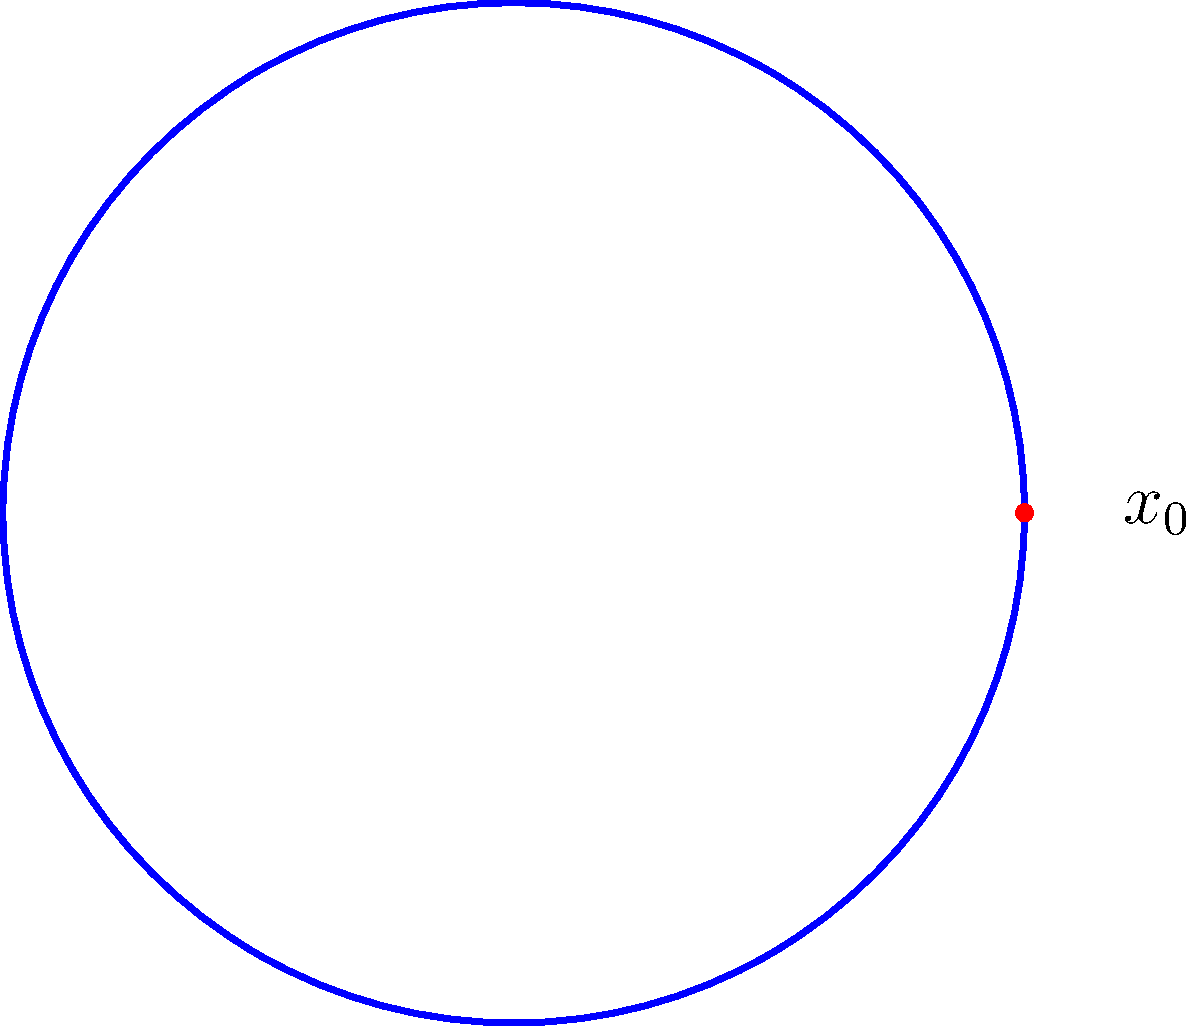Consider the trefoil knot shown in the figure. Calculate the fundamental group of its complement in $\mathbb{R}^3$, $\pi_1(\mathbb{R}^3 - K)$, where $K$ represents the trefoil knot. How does this relate to the unknotting problem in knot theory? To solve this problem, we'll follow these steps:

1) The fundamental group of the complement of a knot is a key invariant in knot theory. For the trefoil knot, we can use the Wirtinger presentation to compute it.

2) The Wirtinger presentation gives generators for each arc of the knot diagram, with relations at each crossing.

3) For the trefoil knot, we have three arcs, so we start with three generators: $a$, $b$, and $c$.

4) At each crossing, we get a relation. For the trefoil, we have:
   $aba^{-1} = c$
   $bcb^{-1} = a$
   $cac^{-1} = b$

5) These relations define the fundamental group of the trefoil knot complement:
   $\pi_1(\mathbb{R}^3 - K) = \langle a, b, c \mid aba^{-1}c^{-1}, bcb^{-1}a^{-1}, cac^{-1}b^{-1} \rangle$

6) This group is non-abelian and is isomorphic to the braid group $B_3$.

7) The fundamental group of the unknot complement is simply $\mathbb{Z}$.

8) Since the fundamental group of the trefoil knot complement is not isomorphic to $\mathbb{Z}$, this proves that the trefoil knot is not equivalent to the unknot.

9) This demonstrates how the fundamental group can be used to distinguish between different knots, which is crucial in the unknotting problem of knot theory.
Answer: $\pi_1(\mathbb{R}^3 - K) = \langle a, b, c \mid aba^{-1}c^{-1}, bcb^{-1}a^{-1}, cac^{-1}b^{-1} \rangle \cong B_3 \neq \mathbb{Z}$, proving the trefoil is knotted. 